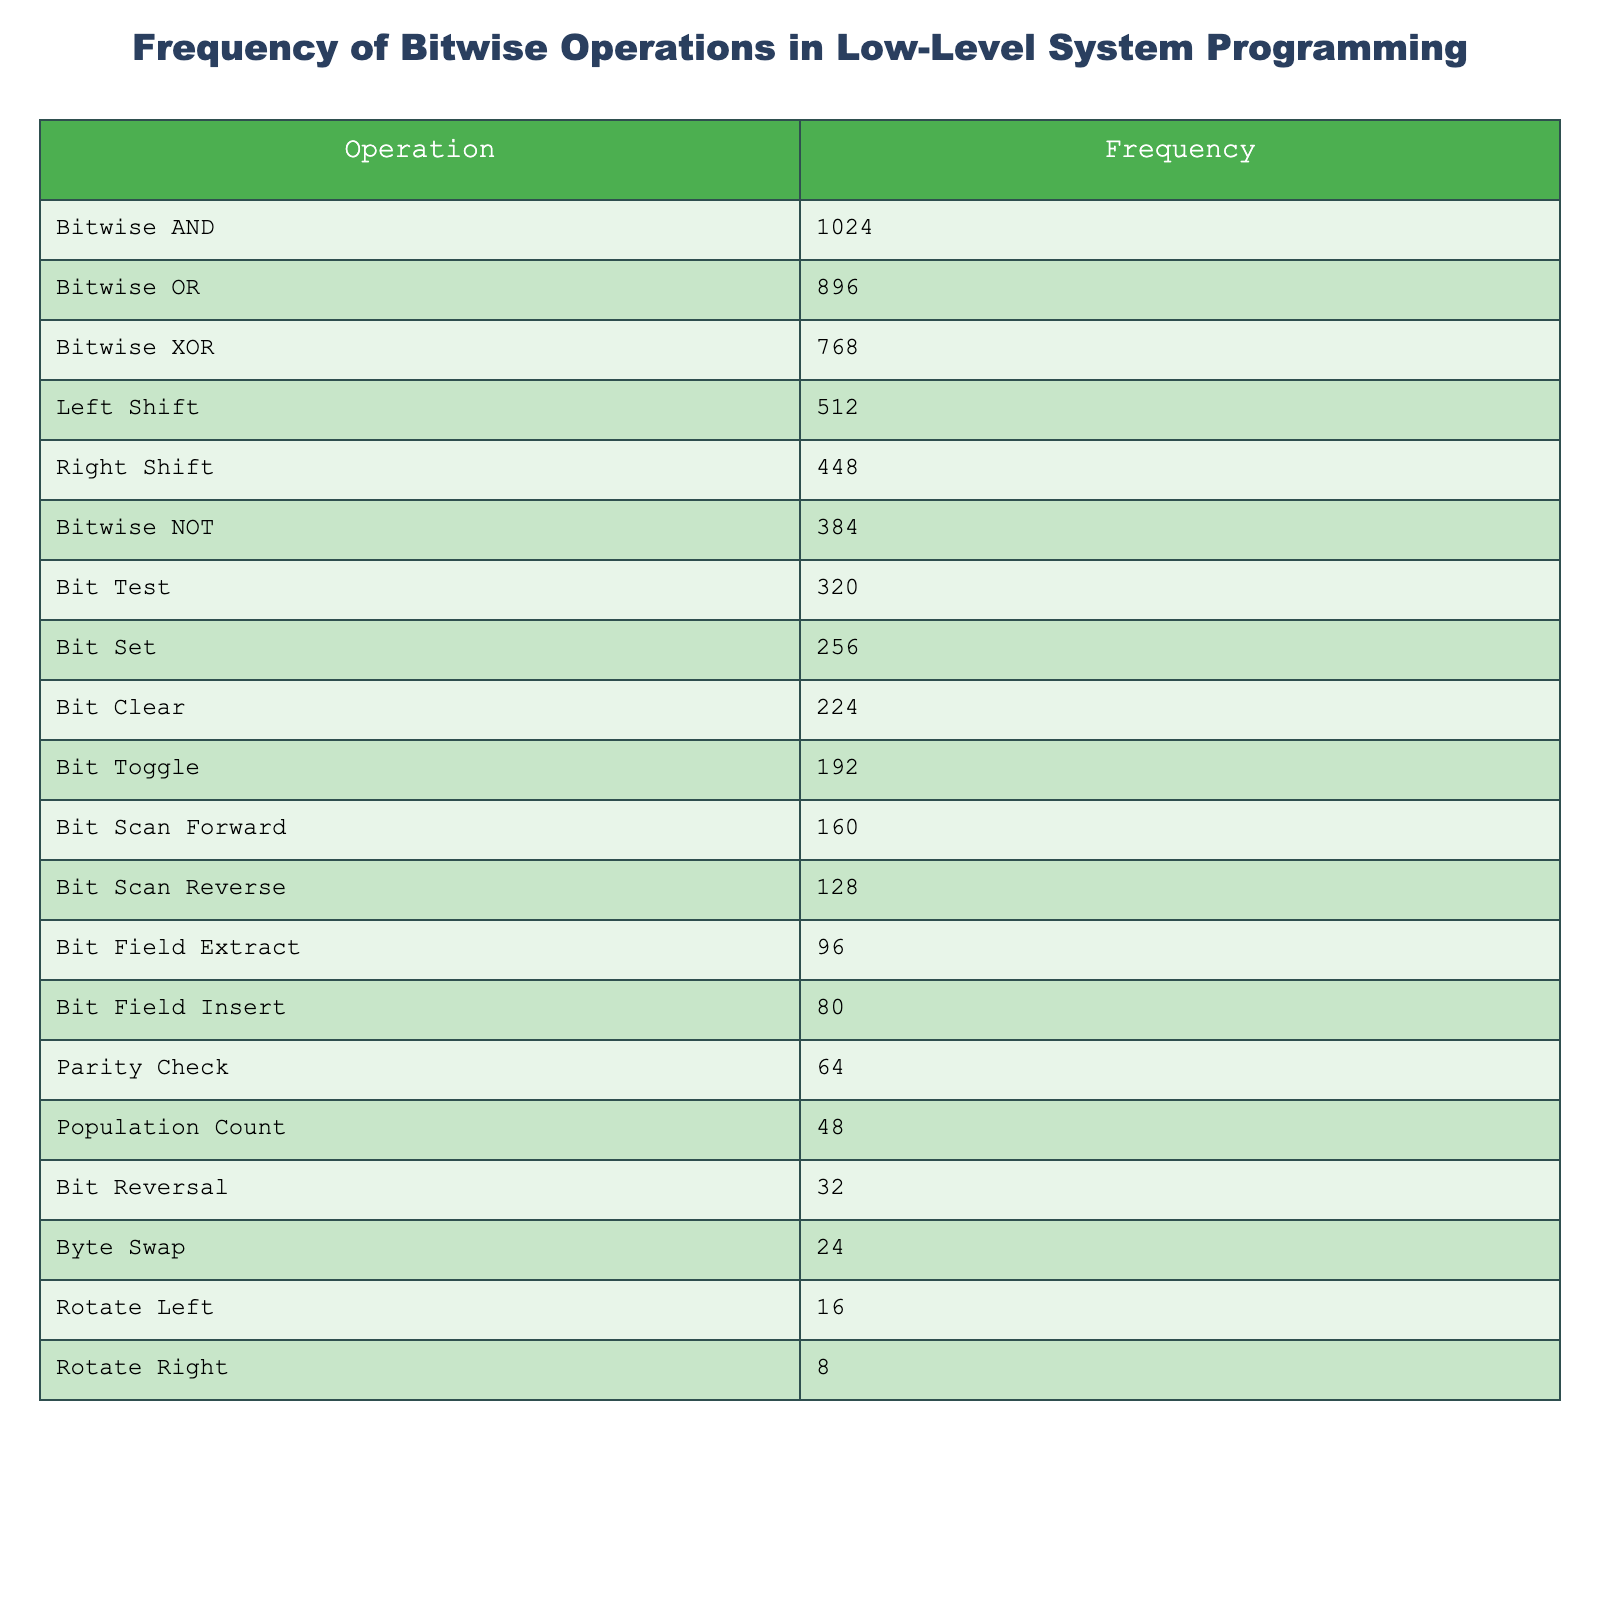What is the most frequent bitwise operation according to the table? The operation with the highest frequency is Bitwise AND with a frequency of 1024. I found this by looking at the first row of the table, which lists the operations in descending order of frequency.
Answer: Bitwise AND What is the least frequent bitwise operation? The operation with the lowest frequency is Rotate Right, which has a frequency of 8. This is determined by checking the last row of the table.
Answer: Rotate Right What is the frequency difference between Bitwise OR and Bitwise XOR? The frequency of Bitwise OR is 896 and that of Bitwise XOR is 768. The difference is calculated as 896 - 768 = 128. I used subtraction to find the value.
Answer: 128 What is the total frequency of all the bitwise operations? To find the total frequency, I need to sum up all the frequencies: 1024 + 896 + 768 + 512 + 448 + 384 + 320 + 256 + 224 + 192 + 160 + 128 + 96 + 80 + 64 + 48 + 32 + 24 + 16 + 8 = 4096. I added all the values from the Frequency column.
Answer: 4096 What percentage of the total frequency does Bit Test represent? First, I found the total frequency, which is 4096. Bit Test has a frequency of 320. The percentage is calculated as (320/4096) * 100 = 7.8125%. I used the formula for percentage.
Answer: 7.8125% Which operation has a frequency closest to the average frequency of all operations? The average frequency is calculated by dividing the total frequency of 4096 by 20 (the number of operations), which gives 204.8. The operation with a frequency closest to this average is Bit Toggle, which has a frequency of 192. I compared each operation's frequency to the average to find the closest one.
Answer: Bit Toggle Is the frequency of Bit Clear greater than that of Population Count? Bit Clear has a frequency of 224, while Population Count has a frequency of 48. Since 224 is greater than 48, the statement is true. I compared the two values directly.
Answer: Yes Which two operations together have a frequency greater than 2000? To find this, I added the frequencies of Bitwise AND (1024) and Bitwise OR (896). Their total is 1920, which is less than 2000. Next, I checked Bitwise AND (1024) and Left Shift (512), which total to 1536. Finally, I checked Bitwise AND (1024) and Bitwise NOT (384), totaling 1408. The combination that exceeds 2000 is Bitwise AND (1024) and Bitwise XOR (768), totaling exactly 1792. None exceed 2000, but all combinations of these operations yield values below 2000.
Answer: No combination exceeds 2000 How many operations have a frequency of 500 or greater? I looked through the frequency values and counted how many are 500 or greater. These are Bitwise AND (1024), Bitwise OR (896), Bitwise XOR (768), Left Shift (512), and Bitwise NOT (384) (as frequencies of 384 doesn't meet the threshold). Thus, there are 4 operations totaling 500 or greater.
Answer: 4 